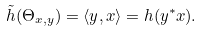<formula> <loc_0><loc_0><loc_500><loc_500>\tilde { h } ( \Theta _ { x , y } ) = \langle y , x \rangle = h ( y ^ { * } x ) .</formula> 